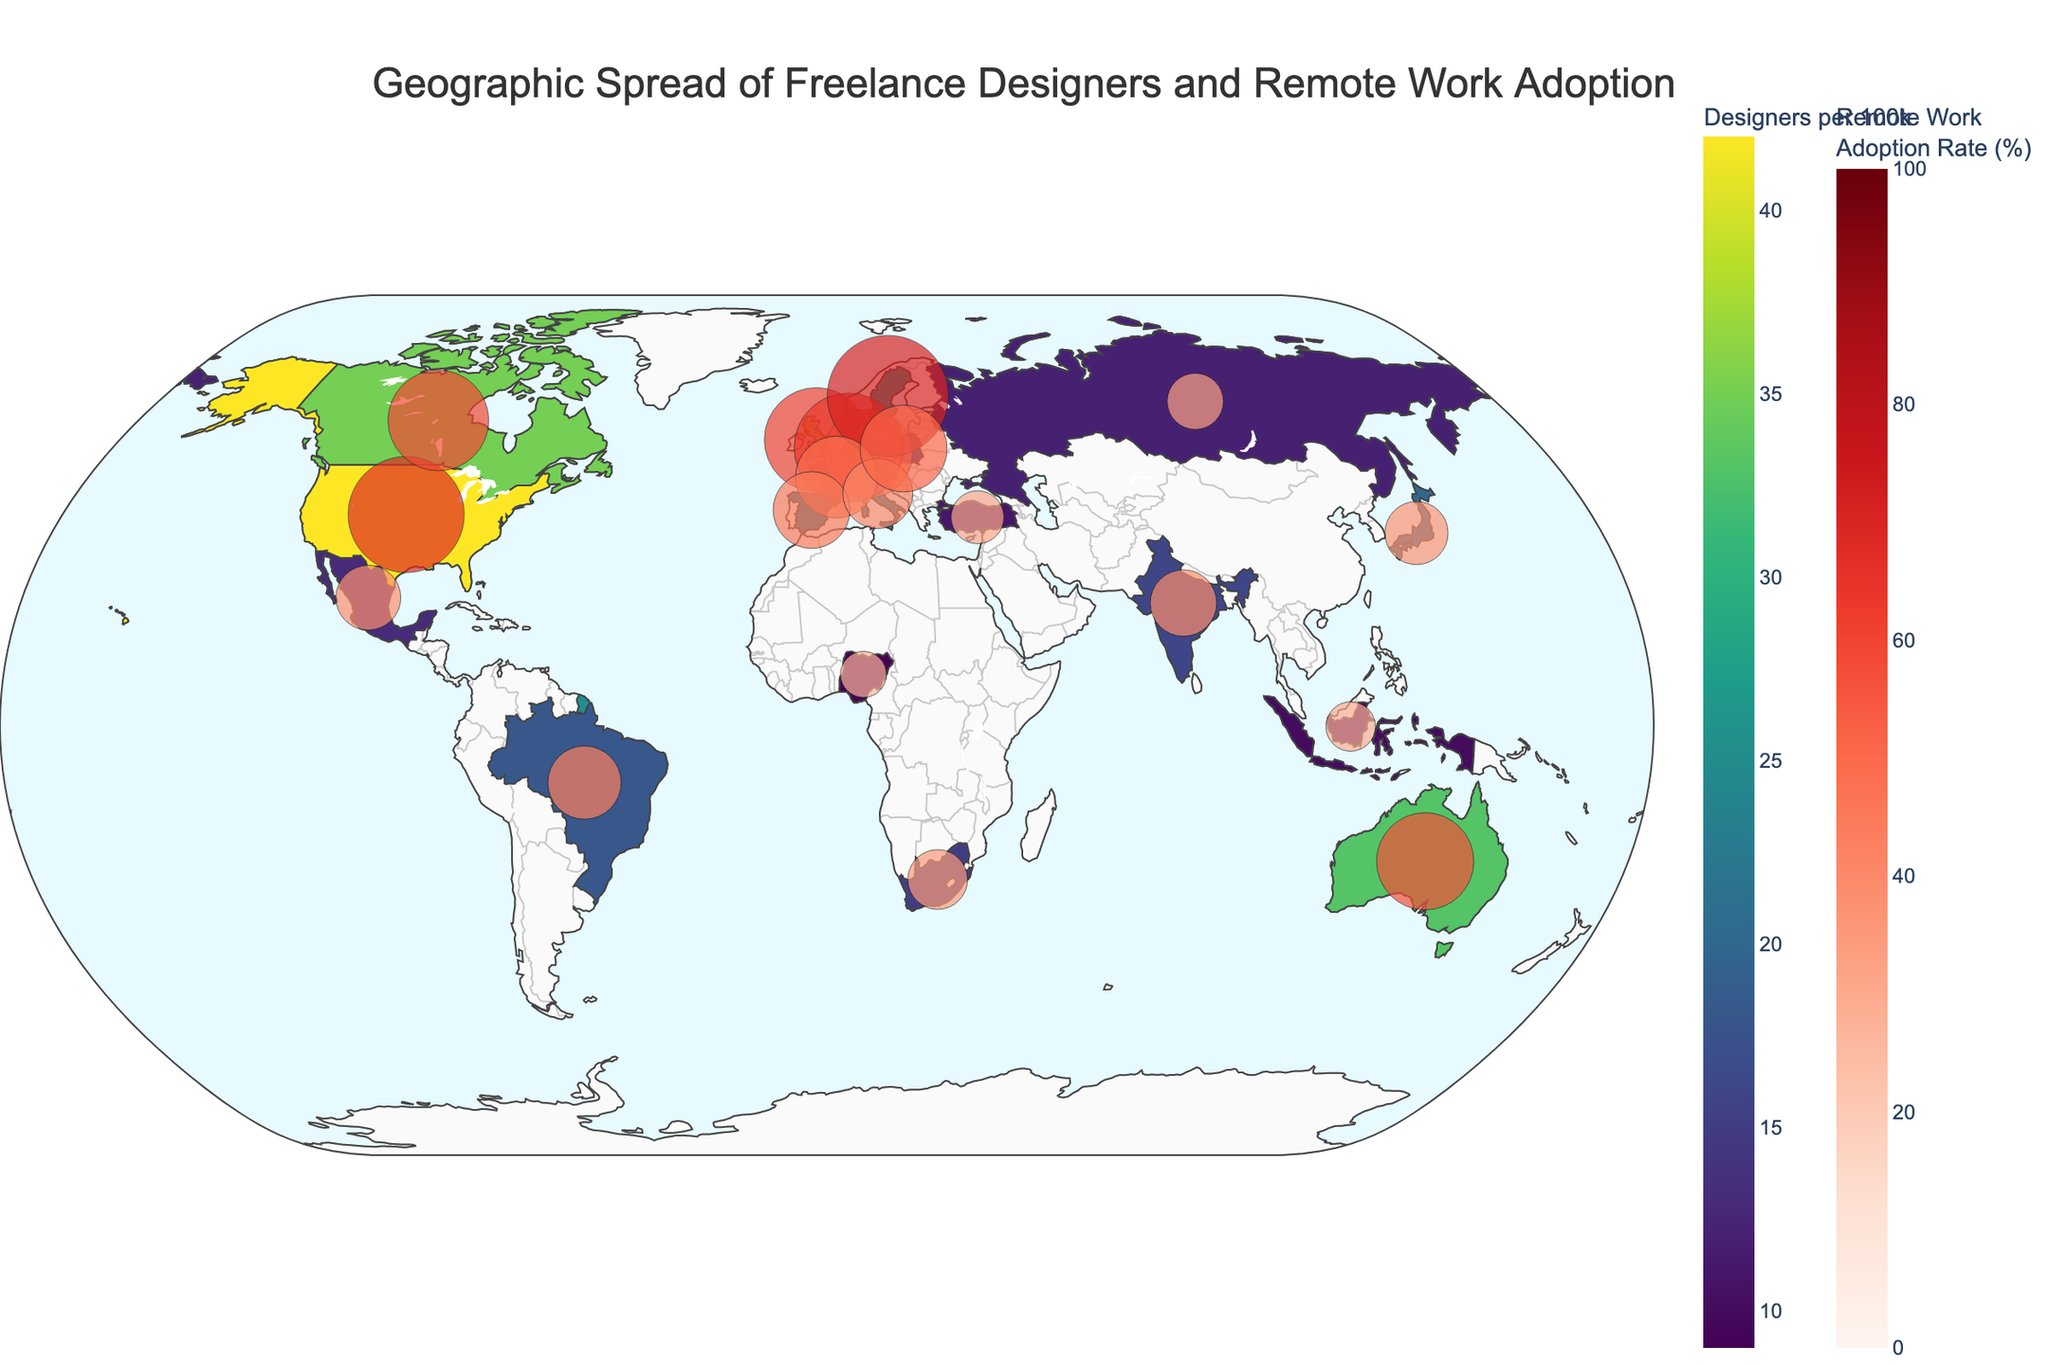What is the title of the figure? The title is located at the top of the figure and summarizes the main topic being visualized. It reads, "Geographic Spread of Freelance Designers and Remote Work Adoption".
Answer: Geographic Spread of Freelance Designers and Remote Work Adoption Which country has the highest Remote Work Adoption Rate? We need to identify the country with the largest circle size and the deepest red color, as these represent the highest Remote Work Adoption Rate. The legend informs that the colorscale represents the percentage. Sweden appears to have the largest and deepest red circle.
Answer: Sweden How many countries have a Freelance Designer rate of 30 or higher per 100k? Count the number of countries from the figure that are shaded in darker colors (as per the colorbar legend) and hover over additional annotations if needed. The countries are the United States, United Kingdom, Canada, Australia, and Germany.
Answer: 5 Compare the Freelance Designers per 100k between the United States and Germany. Which is higher and by how much? According to the figure, the United States has 42 Freelance Designers per 100k while Germany has 30. The difference is calculated as 42 - 30.
Answer: The United States is higher by 12 Which country has the lowest Remote Work Adoption Rate and what is the value? Identify the country with the smallest circle size and the lightest red color on the map. Nigeria appears to have the smallest circle size. The hover data will give the exact percentage.
Answer: Nigeria, 27% What is the average Remote Work Adoption Rate for the countries displayed? We need to sum all the Remote Work Adoption Rates and then divide by the number of countries (20). The sum is 938, thus the average is 938/20.
Answer: 46.9% Identify the two European countries with the closest Freelance Designers per 100k rate and name them. By examining the colors and hovering over European countries, we find that France and Spain have close rates of 25 and 23 respectively.
Answer: France and Spain Which country shows a higher Freelance Designers per 100k rate: Brazil or India? Check the colors for Brazil and India or hover over them, finding 18 for Brazil and 16 for India.
Answer: Brazil List all countries with a Remote Work Adoption Rate above 60%. Hover over each country to check their Remote Work Adoption Rates and collect all those above 60%. These countries are the United States, United Kingdom, Netherlands, and Sweden.
Answer: United States, United Kingdom, Netherlands, Sweden What’s the range of Freelance Designers per 100k across all countries? Identify the maximum and minimum values from the hover data points. The highest is 42 (United States) and the lowest is 9 (Nigeria), thus the range is 42 - 9.
Answer: 33 